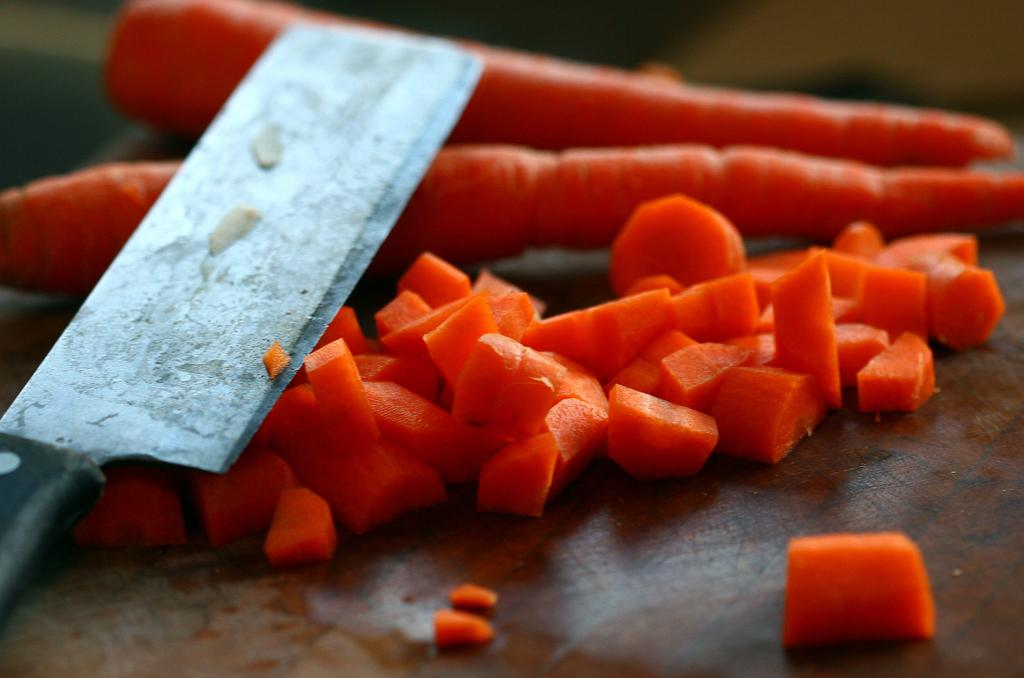What object is present in the image that can be used for cutting? There is a knife in the image. What type of vegetable is present in the image? There are carrots in the image. How are the carrots prepared in the image? There are carrot slices in the image. Where are the knife, carrots, and carrot slices located? The knife, carrots, and carrot slices are on a table. What type of wax is being used to create a sculpture of a worm in the image? There is no wax or worm present in the image; it only features a knife, carrots, and carrot slices on a table. 